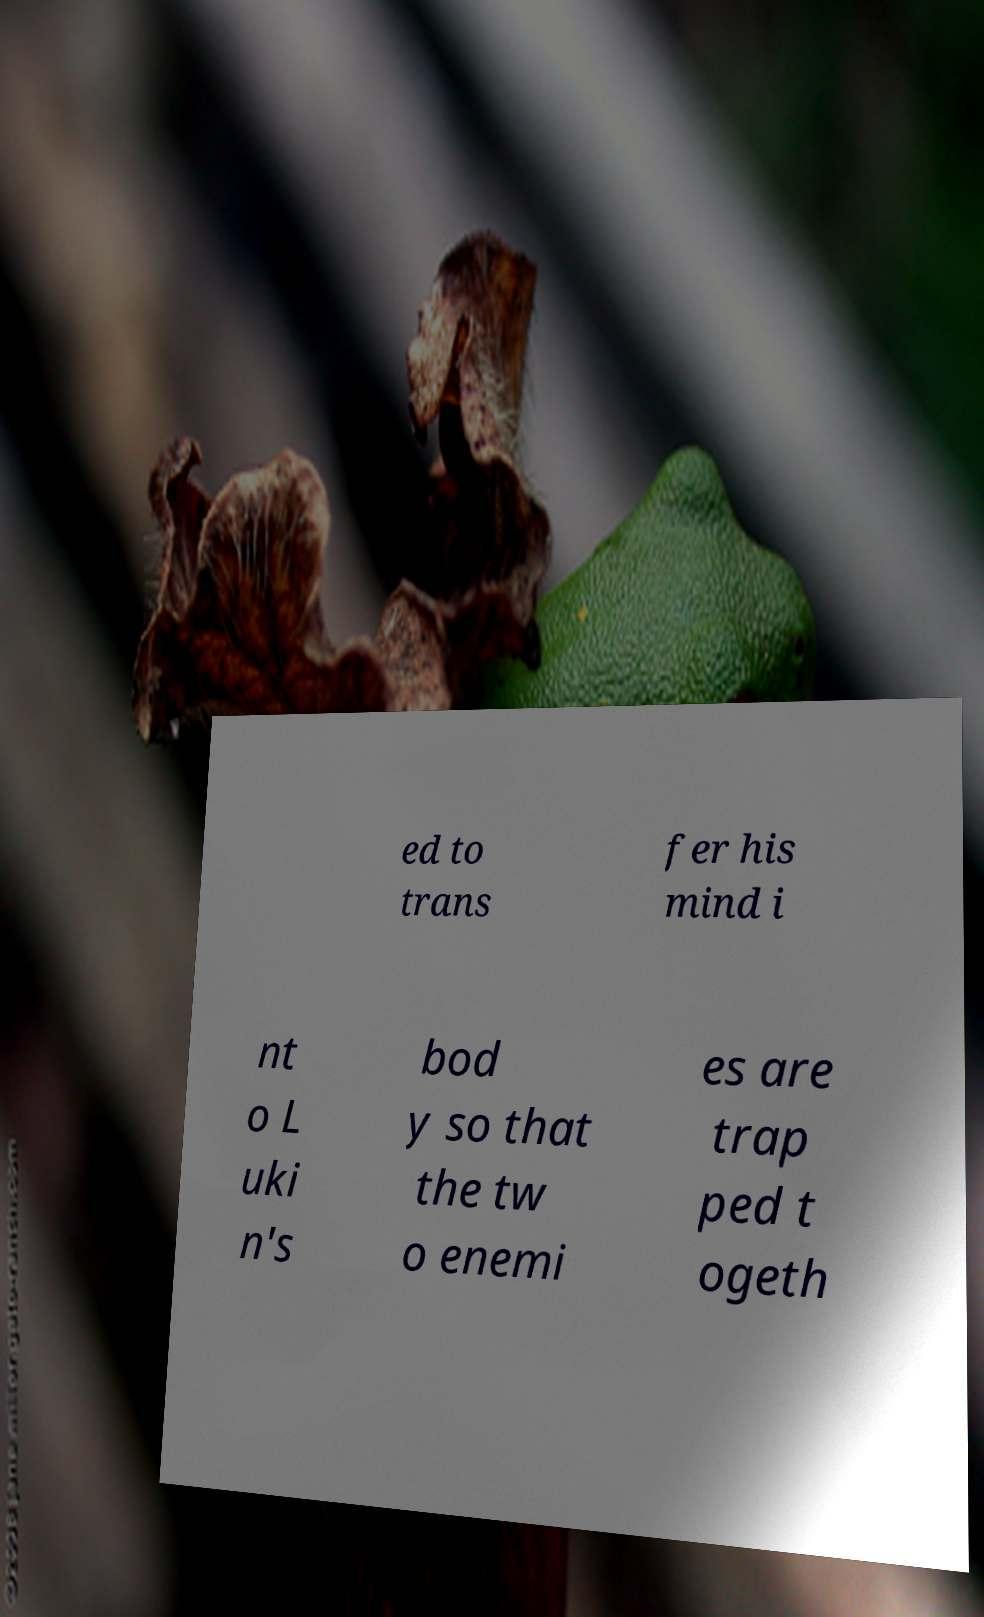For documentation purposes, I need the text within this image transcribed. Could you provide that? ed to trans fer his mind i nt o L uki n's bod y so that the tw o enemi es are trap ped t ogeth 